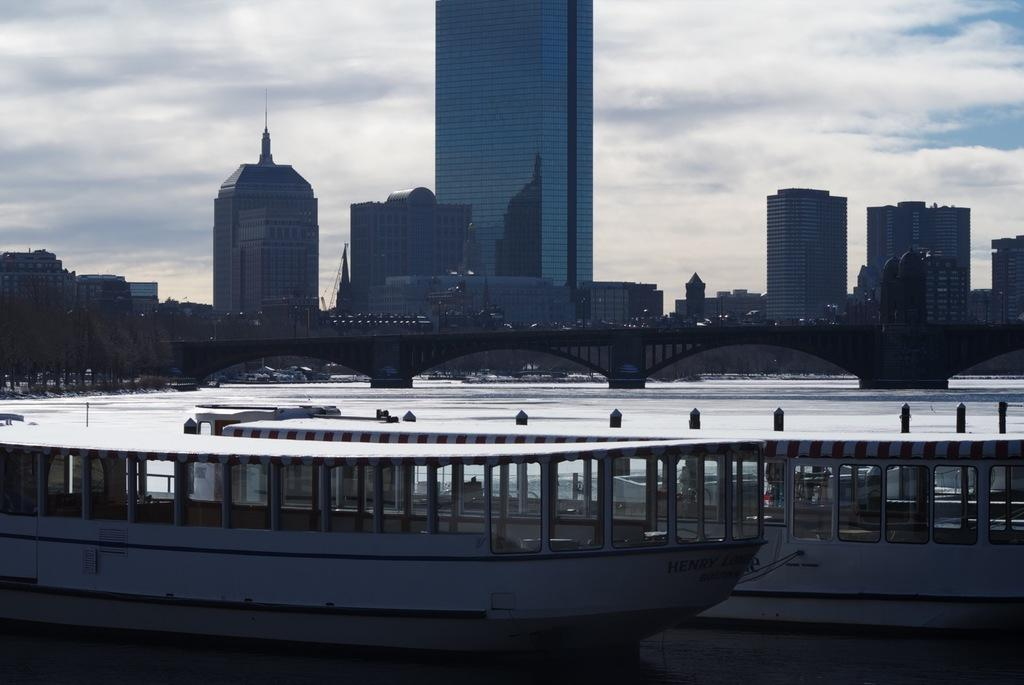What type of structures can be seen in the image? There are buildings in the image. What is present in the water in the image? There are boats in the water in the image. What connects the two sides of the water in the image? There is a bridge in the image. What part of the natural environment is visible in the image? The sky is visible in the image. How would you describe the weather based on the appearance of the sky? The sky appears to be cloudy in the image. What type of pencil can be seen in the image? There is no pencil present in the image. What is the afterthought used for in the image? There is no mention of an afterthought in the image, as it is not a tangible object or concept that can be seen or used. 